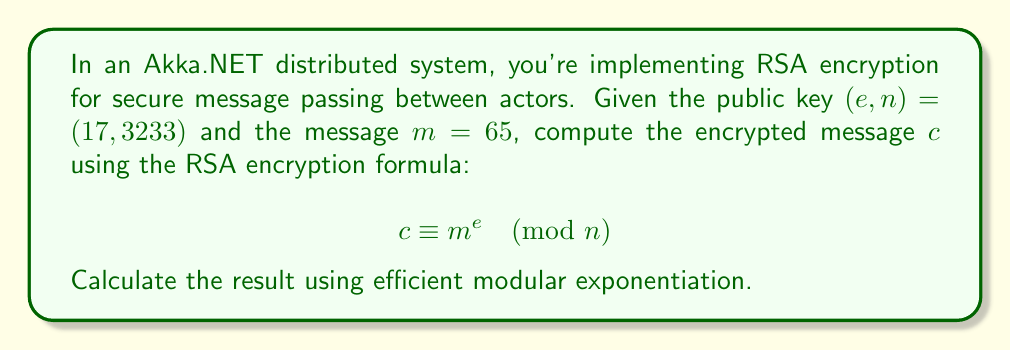Solve this math problem. To efficiently compute $65^{17} \pmod{3233}$, we'll use the square-and-multiply algorithm, which is analogous to the actor model's message passing efficiency:

1) First, convert the exponent 17 to binary: $17_{10} = 10001_2$

2) Initialize: $result = 1$, $base = 65$

3) For each bit in the binary exponent from left to right:
   a) Square the result: $result = result^2 \pmod{3233}$
   b) If the bit is 1, multiply by the base: $result = result \cdot base \pmod{3233}$

Step-by-step calculation:

- Bit 1: $result = 1^2 \cdot 65 \equiv 65 \pmod{3233}$
- Bit 0: $result = 65^2 \equiv 4225 \equiv 992 \pmod{3233}$
- Bit 0: $result = 992^2 \equiv 984064 \equiv 2035 \pmod{3233}$
- Bit 0: $result = 2035^2 \equiv 4141225 \equiv 2627 \pmod{3233}$
- Bit 1: $result = 2627^2 \cdot 65 \equiv 6901129 \cdot 65 \equiv 1690 \cdot 65 \equiv 109850 \equiv 2722 \pmod{3233}$

Therefore, $c \equiv 65^{17} \equiv 2722 \pmod{3233}$
Answer: 2722 